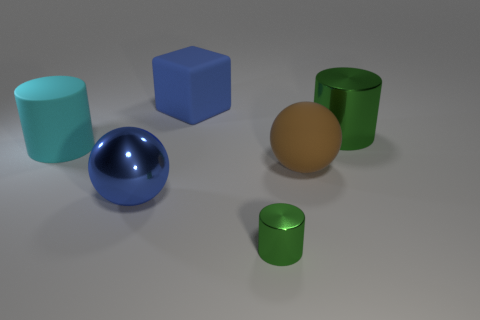Subtract all purple cubes. Subtract all purple cylinders. How many cubes are left? 1 Add 1 tiny cyan matte things. How many objects exist? 7 Subtract all cubes. How many objects are left? 5 Subtract all shiny spheres. Subtract all yellow matte objects. How many objects are left? 5 Add 3 big matte spheres. How many big matte spheres are left? 4 Add 3 large spheres. How many large spheres exist? 5 Subtract 0 yellow balls. How many objects are left? 6 